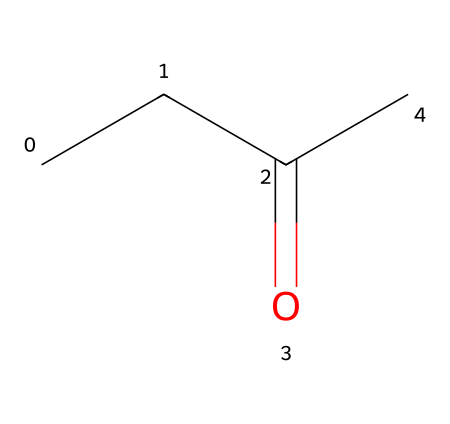What is the molecular formula of this chemical? The chemical has three carbon atoms, eight hydrogen atoms, and one oxygen atom, which can be combined into the molecular formula C4H8O.
Answer: C4H8O How many carbon atoms are present in this chemical? By examining the chemical structure, it's clear that there are four carbon atoms visible in the chain and functional group.
Answer: 4 What type of functional group does this chemical contain? The structure shows a carbonyl group (C=O) part of a ketone functional group, indicative of its classification as a ketone since it is located between two carbon atoms.
Answer: ketone What is the boiling point of methyl ethyl ketone? Methyl ethyl ketone has a boiling point around 79.6 degrees Celsius, which reflects its moderate volatility typical of solvents.
Answer: 79.6 °C Which applications is methyl ethyl ketone commonly used for? Common applications include being used as a solvent in various industrial processes, particularly in cleaning and degreasing operations.
Answer: industrial cleaning agent What is a primary health hazard associated with methyl ethyl ketone? Exposure to this chemical can lead to respiratory issues and skin irritation, recognizing its potential hazards in the workplace.
Answer: respiratory issues Is methyl ethyl ketone flammable? The chemical structure indicates it has flammable properties due to the presence of carbon and hydrogen, making it volatile.
Answer: yes 